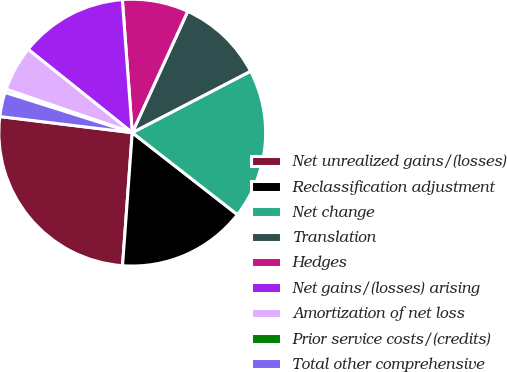Convert chart to OTSL. <chart><loc_0><loc_0><loc_500><loc_500><pie_chart><fcel>Net unrealized gains/(losses)<fcel>Reclassification adjustment<fcel>Net change<fcel>Translation<fcel>Hedges<fcel>Net gains/(losses) arising<fcel>Amortization of net loss<fcel>Prior service costs/(credits)<fcel>Total other comprehensive<nl><fcel>25.77%<fcel>15.62%<fcel>18.16%<fcel>10.55%<fcel>8.01%<fcel>13.08%<fcel>5.47%<fcel>0.4%<fcel>2.94%<nl></chart> 